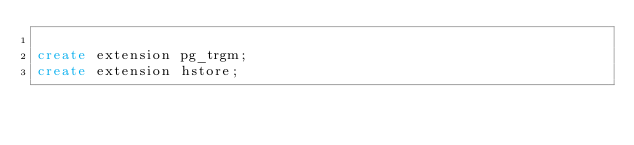Convert code to text. <code><loc_0><loc_0><loc_500><loc_500><_SQL_>
create extension pg_trgm;
create extension hstore;</code> 